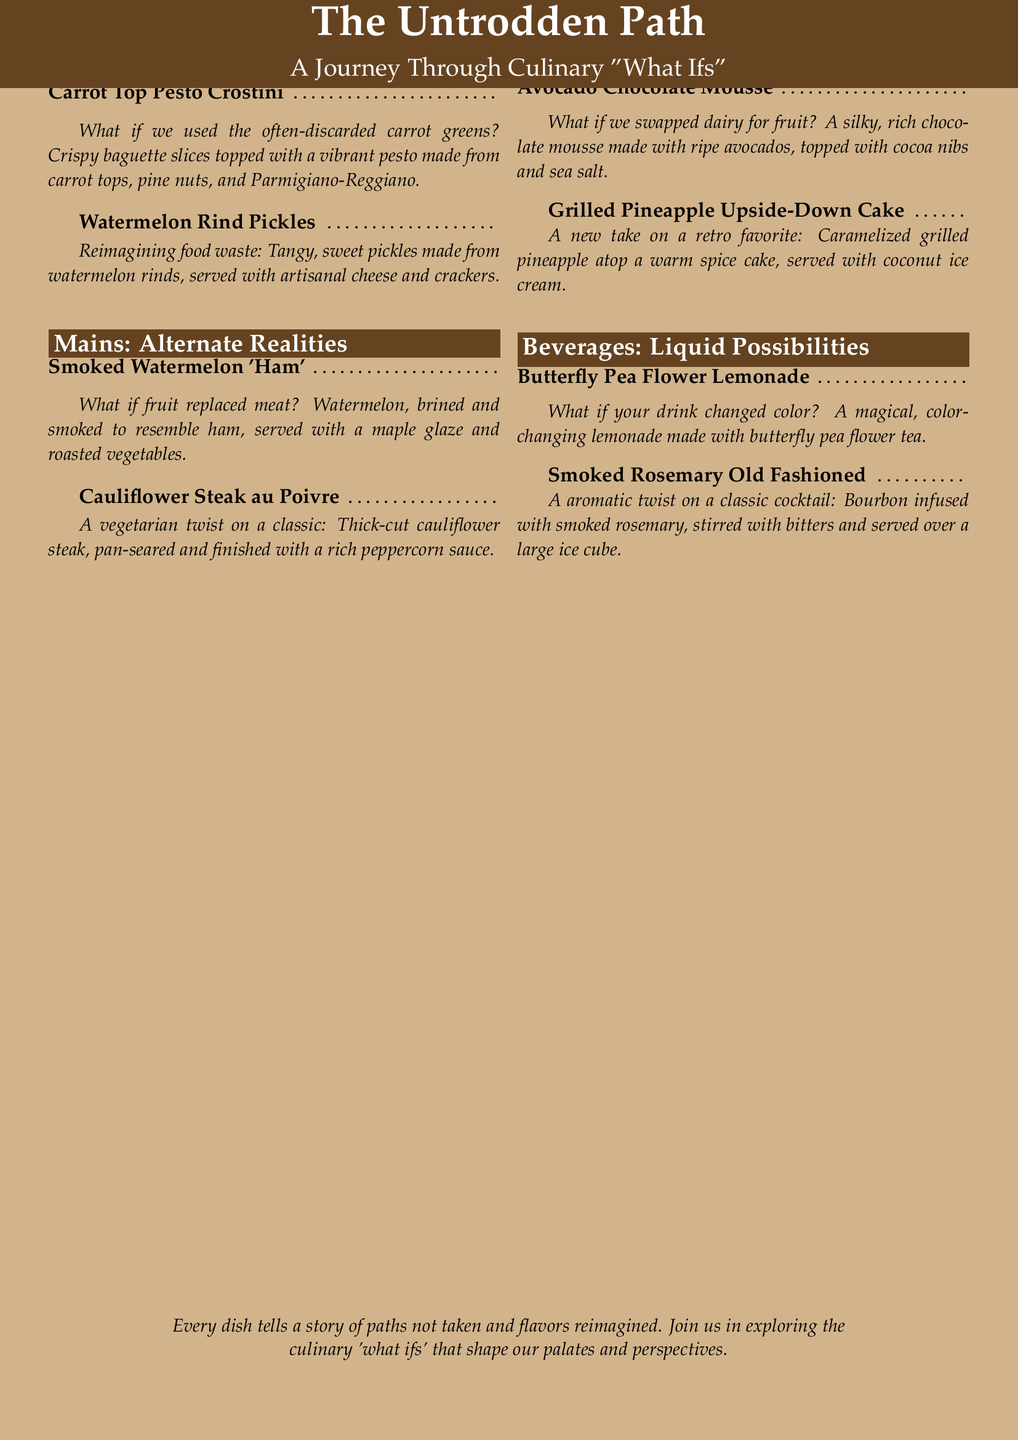What is the title of the menu? The title of the menu is prominently displayed at the top of the document and reads "The Untrodden Path".
Answer: The Untrodden Path How many sections are there in the menu? The menu has four distinct sections: Appetizers, Mains, Desserts, and Beverages.
Answer: Four What ingredient is used in the Carrot Top Pesto Crostini? The Carrot Top Pesto Crostini features an ingredient that is often discarded, specifically carrot greens.
Answer: Carrot greens What beverage features a color-changing property? The menu describes a beverage that changes color, specifically made with butterfly pea flower tea.
Answer: Butterfly Pea Flower Lemonade Which dish substitutes meat with fruit? The dish that replaces meat is the Smoked Watermelon 'Ham', which uses watermelon instead.
Answer: Smoked Watermelon 'Ham' What is the main ingredient in the Avocado Chocolate Mousse? The main ingredient that replaces dairy in the Avocado Chocolate Mousse is ripe avocados.
Answer: Ripe avocados What would Cauliflower Steak au Poivre be considered? This dish is identified as a vegetarian twist on a classic meat dish.
Answer: Vegetarian twist Which dessert is served with coconut ice cream? The dessert that is paired with coconut ice cream is the Grilled Pineapple Upside-Down Cake.
Answer: Grilled Pineapple Upside-Down Cake What cooking method is used for the Cauliflower Steak? The Cauliflower Steak is prepared by being pan-seared, which indicates a specific cooking method.
Answer: Pan-seared 